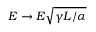<formula> <loc_0><loc_0><loc_500><loc_500>E \rightarrow E \sqrt { \gamma L / \alpha }</formula> 